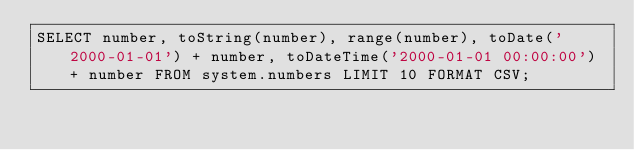Convert code to text. <code><loc_0><loc_0><loc_500><loc_500><_SQL_>SELECT number, toString(number), range(number), toDate('2000-01-01') + number, toDateTime('2000-01-01 00:00:00') + number FROM system.numbers LIMIT 10 FORMAT CSV;
</code> 